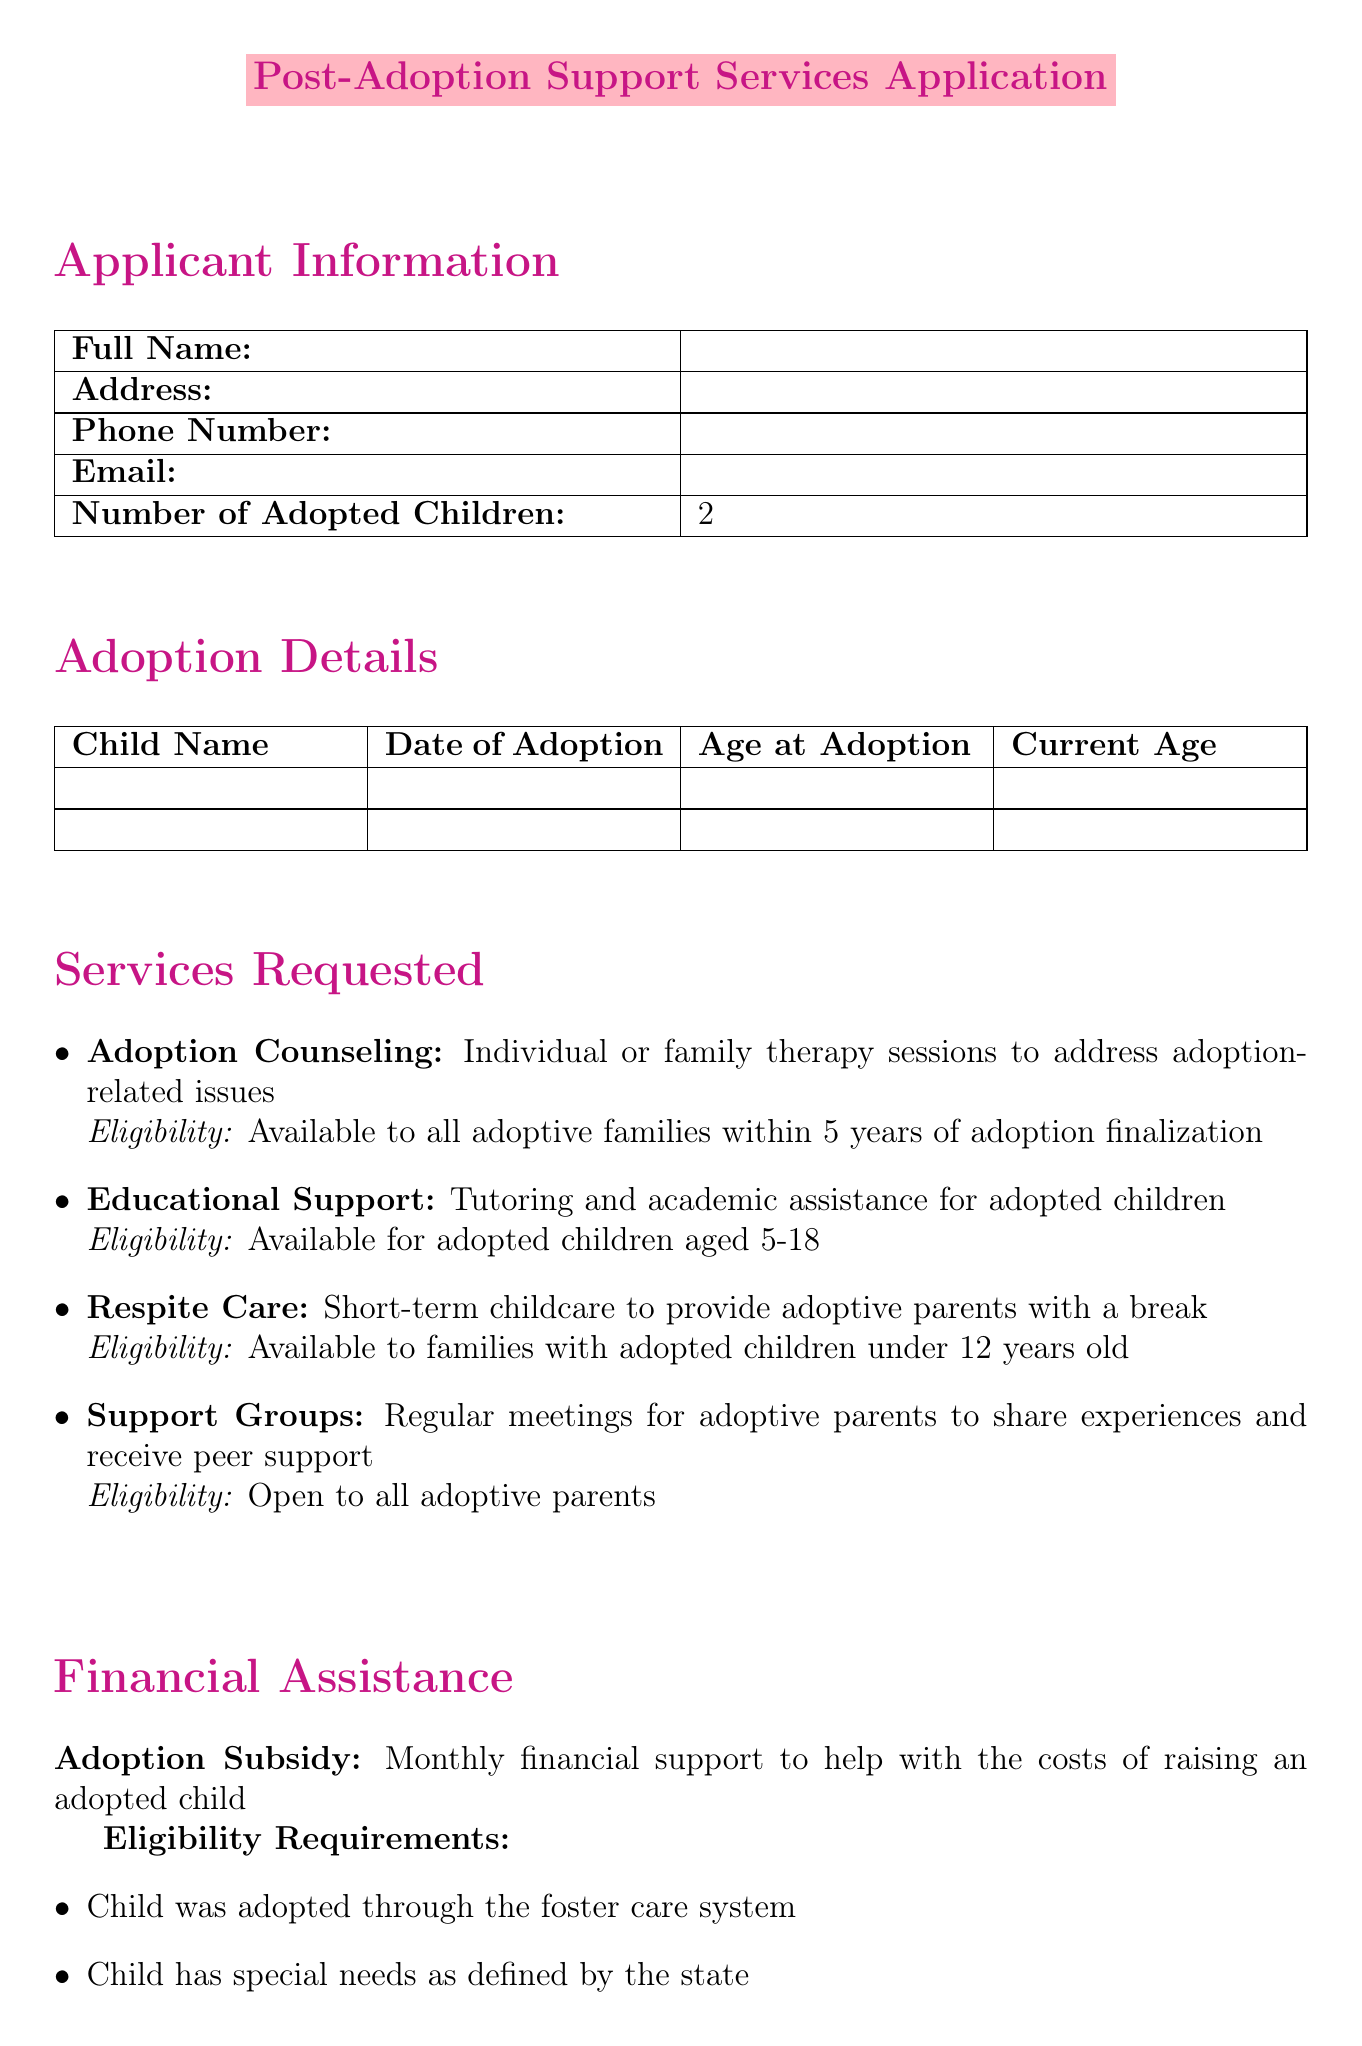What is the title of the document? The title is the main heading presented at the top of the document.
Answer: Post-Adoption Support Services Application How many adopted children does the applicant have? The document specifies the number of adopted children in the applicant's information section.
Answer: 2 What service offers therapy sessions for adoptive families? The service name includes "therapy sessions" and is mentioned in the services requested section.
Answer: Adoption Counseling What is the eligibility for Educational Support? The eligibility criteria are specified alongside each service in the document.
Answer: Available for adopted children aged 5-18 What is required for the Adoption Subsidy eligibility? The eligibility requirements are listed under the financial assistance section regarding the subsidy.
Answer: Child was adopted through the foster care system What is the contact phone number for the Adoptive Families Association? This information is found in the community resources section and provides a means of contact.
Answer: (555) 123-4567 What document is required to prove child's special needs? This document is listed under the required documents for the financial assistance application.
Answer: Documentation of child's special needs Who can join the Support Groups? The eligibility criteria specify who the support groups are open to in the services requested section.
Answer: Open to all adoptive parents 